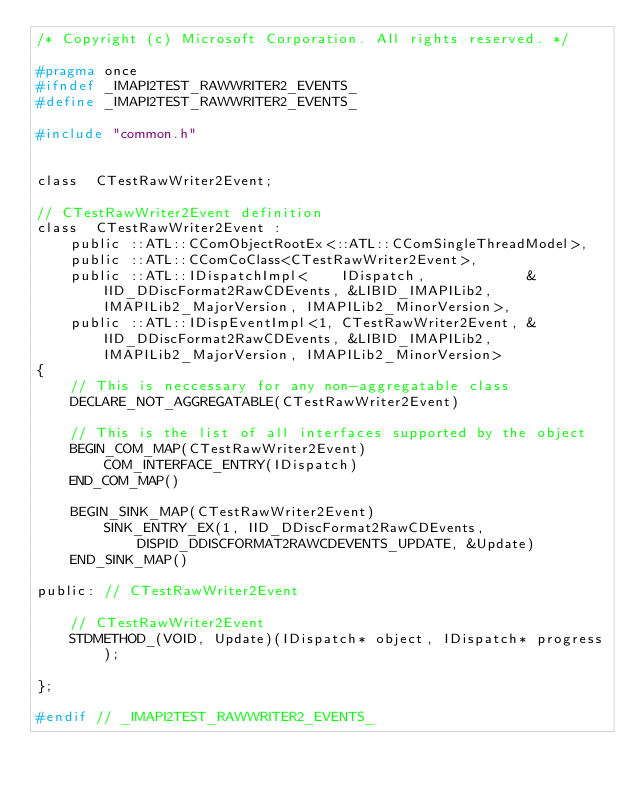<code> <loc_0><loc_0><loc_500><loc_500><_C_>/* Copyright (c) Microsoft Corporation. All rights reserved. */

#pragma once
#ifndef _IMAPI2TEST_RAWWRITER2_EVENTS_
#define _IMAPI2TEST_RAWWRITER2_EVENTS_

#include "common.h"


class  CTestRawWriter2Event;

// CTestRawWriter2Event definition
class  CTestRawWriter2Event :
    public ::ATL::CComObjectRootEx<::ATL::CComSingleThreadModel>,
    public ::ATL::CComCoClass<CTestRawWriter2Event>,
    public ::ATL::IDispatchImpl<    IDispatch,            &IID_DDiscFormat2RawCDEvents, &LIBID_IMAPILib2, IMAPILib2_MajorVersion, IMAPILib2_MinorVersion>,
    public ::ATL::IDispEventImpl<1, CTestRawWriter2Event, &IID_DDiscFormat2RawCDEvents, &LIBID_IMAPILib2, IMAPILib2_MajorVersion, IMAPILib2_MinorVersion>
{
    // This is neccessary for any non-aggregatable class
    DECLARE_NOT_AGGREGATABLE(CTestRawWriter2Event)

    // This is the list of all interfaces supported by the object
    BEGIN_COM_MAP(CTestRawWriter2Event)
        COM_INTERFACE_ENTRY(IDispatch)
    END_COM_MAP()

    BEGIN_SINK_MAP(CTestRawWriter2Event)
        SINK_ENTRY_EX(1, IID_DDiscFormat2RawCDEvents, DISPID_DDISCFORMAT2RAWCDEVENTS_UPDATE, &Update)
    END_SINK_MAP()

public: // CTestRawWriter2Event

    // CTestRawWriter2Event
    STDMETHOD_(VOID, Update)(IDispatch* object, IDispatch* progress);

};

#endif // _IMAPI2TEST_RAWWRITER2_EVENTS_
</code> 